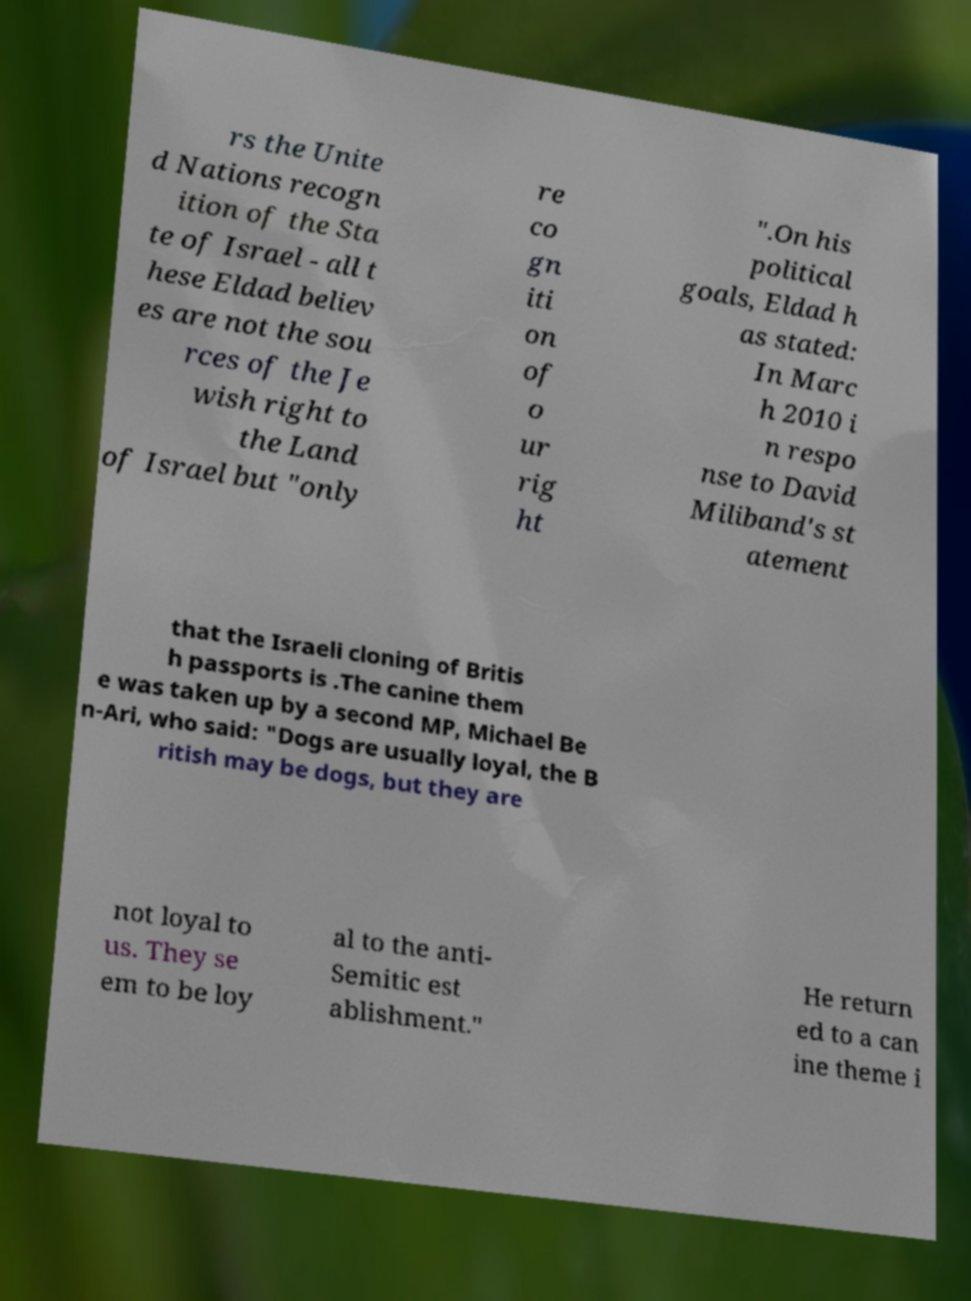Could you extract and type out the text from this image? rs the Unite d Nations recogn ition of the Sta te of Israel - all t hese Eldad believ es are not the sou rces of the Je wish right to the Land of Israel but "only re co gn iti on of o ur rig ht ".On his political goals, Eldad h as stated: In Marc h 2010 i n respo nse to David Miliband's st atement that the Israeli cloning of Britis h passports is .The canine them e was taken up by a second MP, Michael Be n-Ari, who said: "Dogs are usually loyal, the B ritish may be dogs, but they are not loyal to us. They se em to be loy al to the anti- Semitic est ablishment." He return ed to a can ine theme i 